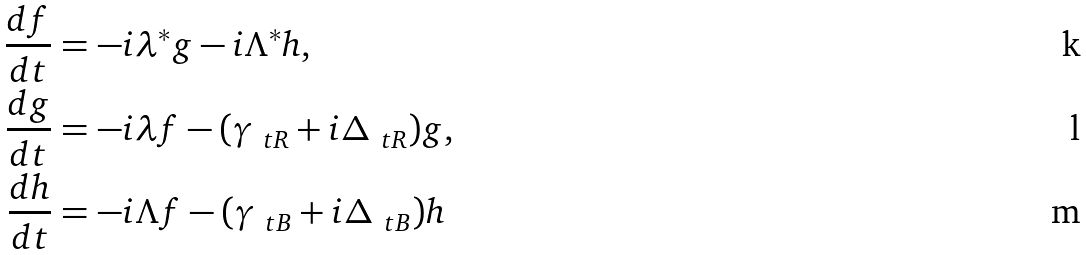Convert formula to latex. <formula><loc_0><loc_0><loc_500><loc_500>\frac { d f } { d t } & = - i \lambda ^ { * } g - i \Lambda ^ { * } h , \\ \frac { d g } { d t } & = - i \lambda f - ( \gamma _ { \ t R } + i \Delta _ { \ t R } ) g , \\ \frac { d h } { d t } & = - i \Lambda f - ( \gamma _ { \ t B } + i \Delta _ { \ t B } ) h</formula> 